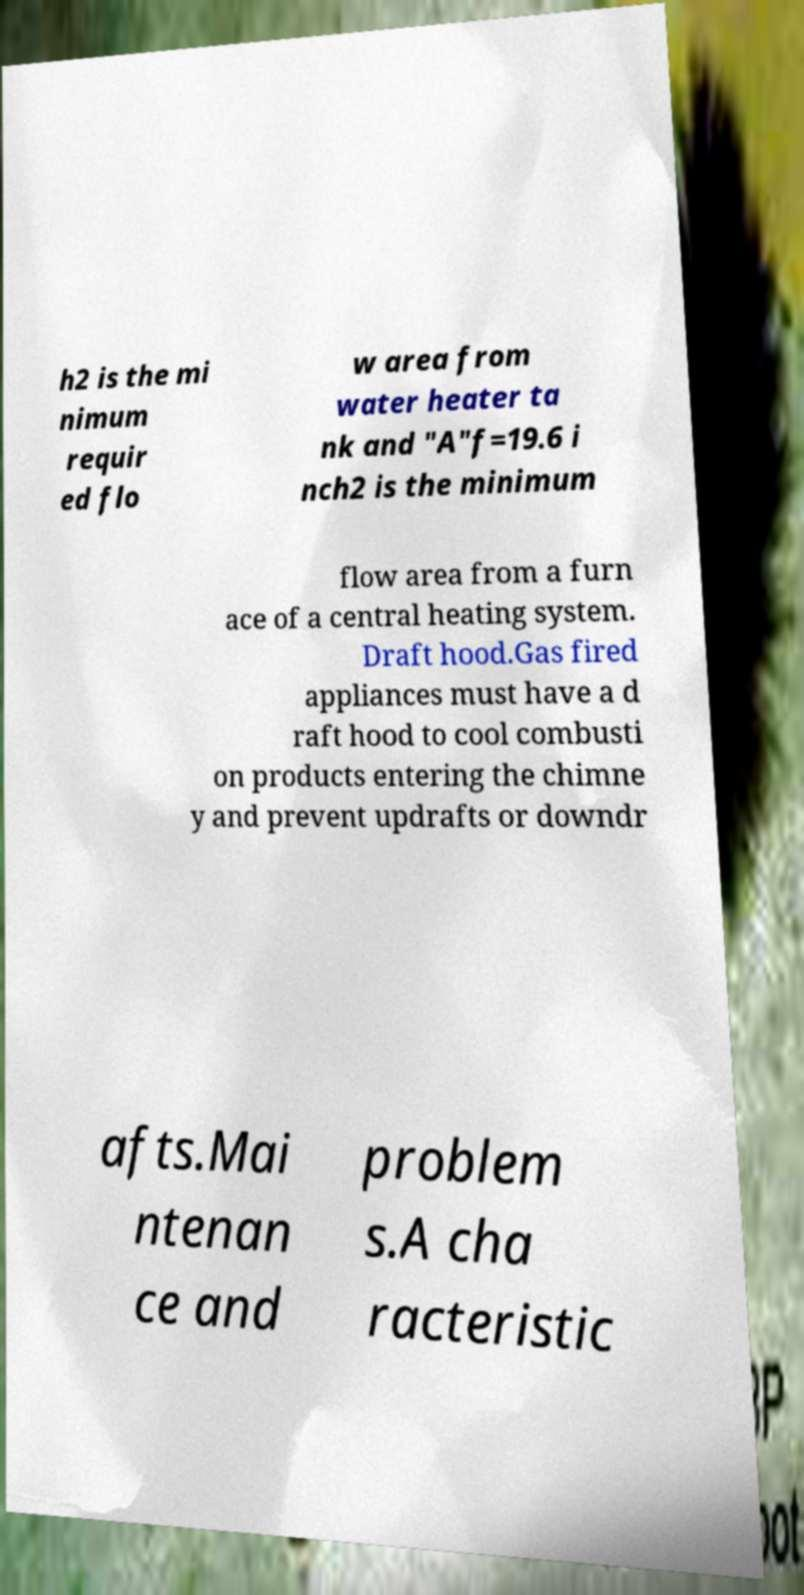For documentation purposes, I need the text within this image transcribed. Could you provide that? h2 is the mi nimum requir ed flo w area from water heater ta nk and "A"f=19.6 i nch2 is the minimum flow area from a furn ace of a central heating system. Draft hood.Gas fired appliances must have a d raft hood to cool combusti on products entering the chimne y and prevent updrafts or downdr afts.Mai ntenan ce and problem s.A cha racteristic 